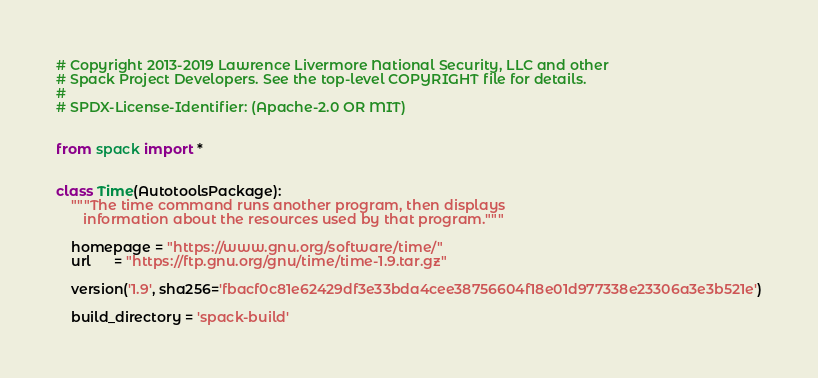Convert code to text. <code><loc_0><loc_0><loc_500><loc_500><_Python_># Copyright 2013-2019 Lawrence Livermore National Security, LLC and other
# Spack Project Developers. See the top-level COPYRIGHT file for details.
#
# SPDX-License-Identifier: (Apache-2.0 OR MIT)


from spack import *


class Time(AutotoolsPackage):
    """The time command runs another program, then displays
       information about the resources used by that program."""

    homepage = "https://www.gnu.org/software/time/"
    url      = "https://ftp.gnu.org/gnu/time/time-1.9.tar.gz"

    version('1.9', sha256='fbacf0c81e62429df3e33bda4cee38756604f18e01d977338e23306a3e3b521e')

    build_directory = 'spack-build'
</code> 